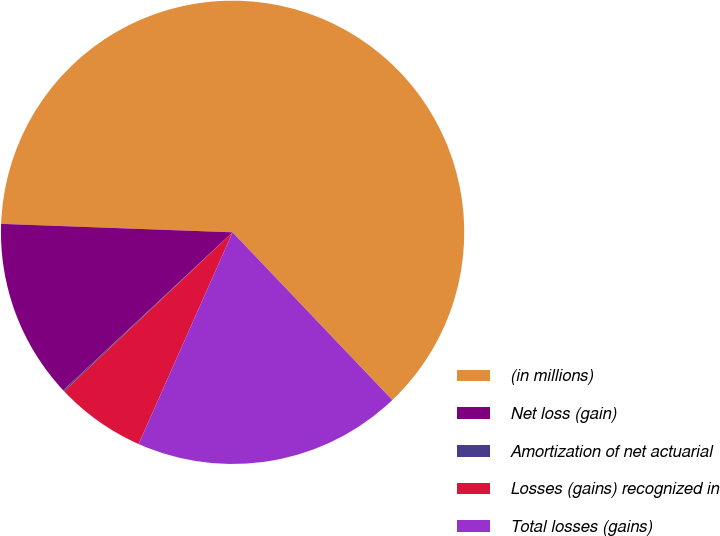Convert chart. <chart><loc_0><loc_0><loc_500><loc_500><pie_chart><fcel>(in millions)<fcel>Net loss (gain)<fcel>Amortization of net actuarial<fcel>Losses (gains) recognized in<fcel>Total losses (gains)<nl><fcel>62.3%<fcel>12.53%<fcel>0.09%<fcel>6.31%<fcel>18.76%<nl></chart> 